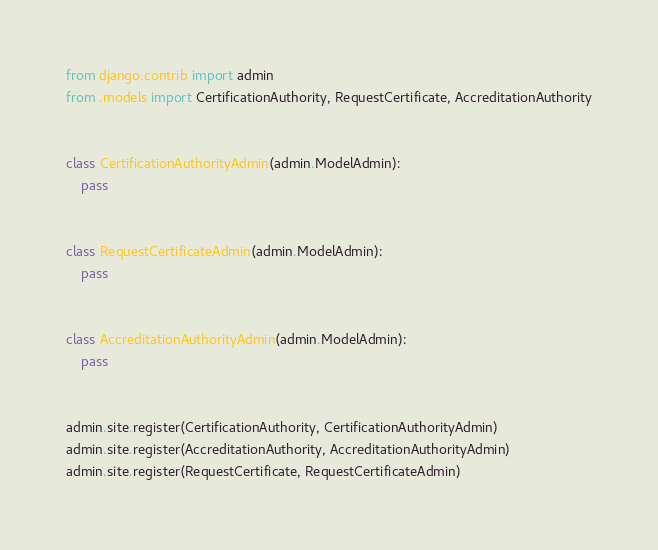Convert code to text. <code><loc_0><loc_0><loc_500><loc_500><_Python_>from django.contrib import admin
from .models import CertificationAuthority, RequestCertificate, AccreditationAuthority


class CertificationAuthorityAdmin(admin.ModelAdmin):
    pass


class RequestCertificateAdmin(admin.ModelAdmin):
    pass


class AccreditationAuthorityAdmin(admin.ModelAdmin):
    pass


admin.site.register(CertificationAuthority, CertificationAuthorityAdmin)
admin.site.register(AccreditationAuthority, AccreditationAuthorityAdmin)
admin.site.register(RequestCertificate, RequestCertificateAdmin)
</code> 